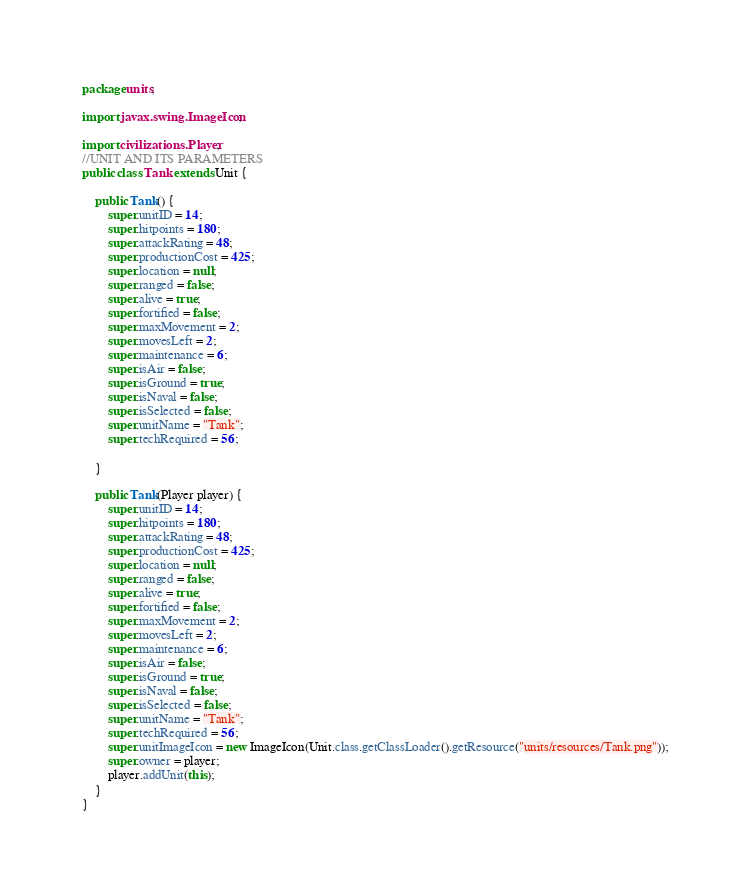<code> <loc_0><loc_0><loc_500><loc_500><_Java_>package units;

import javax.swing.ImageIcon;

import civilizations.Player;
//UNIT AND ITS PARAMETERS
public class Tank extends Unit {

	public Tank() {
		super.unitID = 14;
		super.hitpoints = 180;
		super.attackRating = 48;
		super.productionCost = 425;
		super.location = null;
		super.ranged = false;
		super.alive = true;
		super.fortified = false;
		super.maxMovement = 2;
		super.movesLeft = 2;
		super.maintenance = 6;
		super.isAir = false;
		super.isGround = true;
		super.isNaval = false;
		super.isSelected = false;
		super.unitName = "Tank";
		super.techRequired = 56;
		
	}

	public Tank(Player player) {
		super.unitID = 14;
		super.hitpoints = 180;
		super.attackRating = 48;
		super.productionCost = 425;
		super.location = null;
		super.ranged = false;
		super.alive = true;
		super.fortified = false;
		super.maxMovement = 2;
		super.movesLeft = 2;
		super.maintenance = 6;
		super.isAir = false;
		super.isGround = true;
		super.isNaval = false;
		super.isSelected = false;
		super.unitName = "Tank";
		super.techRequired = 56;
		super.unitImageIcon = new ImageIcon(Unit.class.getClassLoader().getResource("units/resources/Tank.png"));
		super.owner = player;
		player.addUnit(this);
	}
}
</code> 